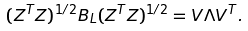Convert formula to latex. <formula><loc_0><loc_0><loc_500><loc_500>( Z ^ { T } Z ) ^ { 1 / 2 } B _ { L } ( Z ^ { T } Z ) ^ { 1 / 2 } = V \Lambda V ^ { T } .</formula> 